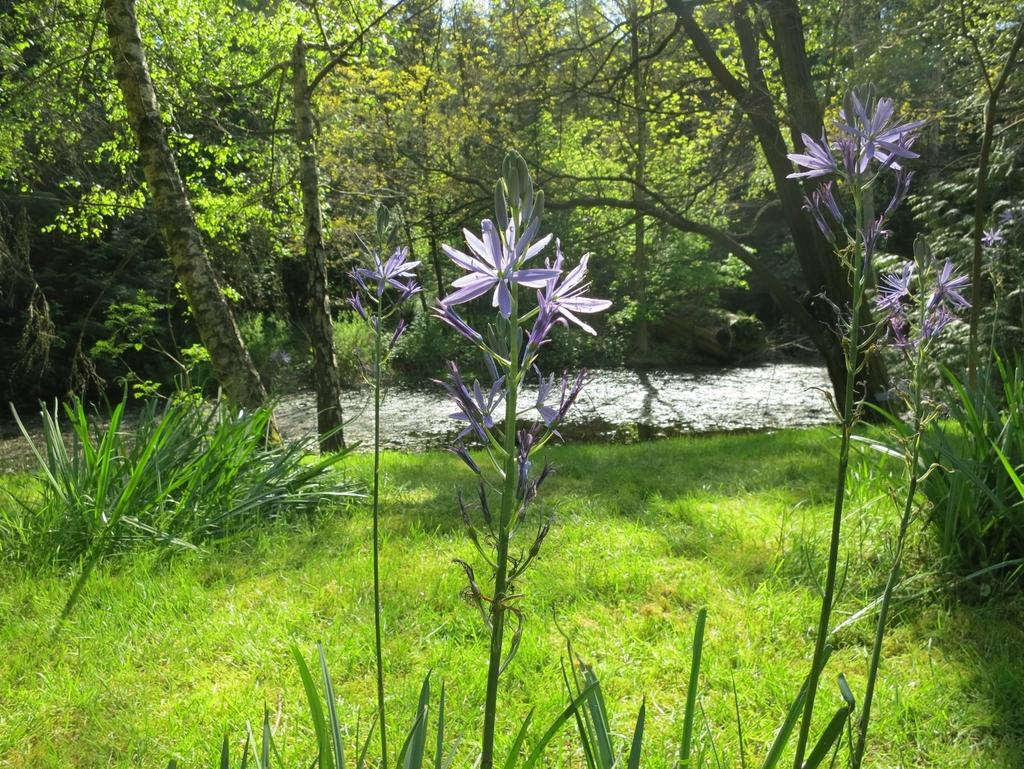What type of plants can be seen in the image? There are flowers, stems, and plants visible in the image. What is on the ground in the image? There is grass on the ground in the image. What can be seen in the background of the image? There is water, tree trunks, and leaves visible in the background of the image. What type of poison is being used by the governor in the image? There is no governor or poison present in the image. Can you tell me how many branches are visible in the image? There are no branches visible in the image; only tree trunks and leaves are present in the background. 